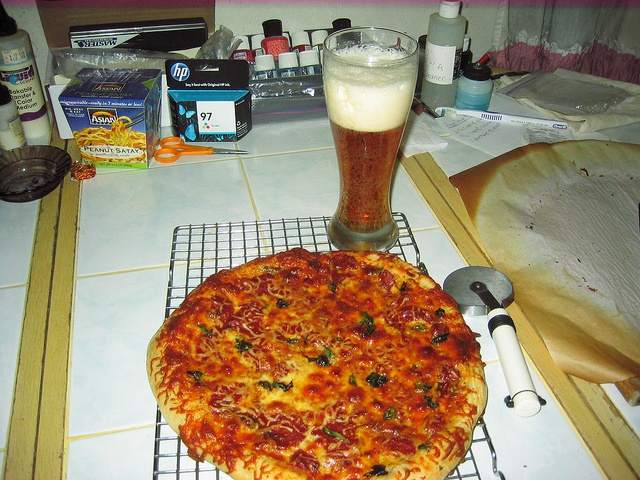Describe the objects in this image and their specific colors. I can see pizza in black, brown, red, and orange tones, cup in black, maroon, beige, and darkgray tones, bottle in black, gray, lightgray, and darkgray tones, bottle in black, gray, and darkgray tones, and bowl in black, darkgreen, and gray tones in this image. 